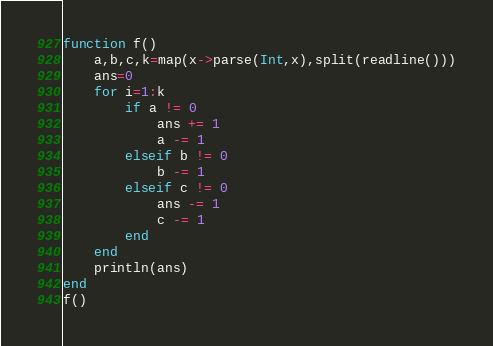Convert code to text. <code><loc_0><loc_0><loc_500><loc_500><_Julia_>function f()
    a,b,c,k=map(x->parse(Int,x),split(readline()))
    ans=0
    for i=1:k
        if a != 0
            ans += 1
            a -= 1
        elseif b != 0
            b -= 1
        elseif c != 0
            ans -= 1
            c -= 1
        end
    end
    println(ans)
end
f()           
</code> 